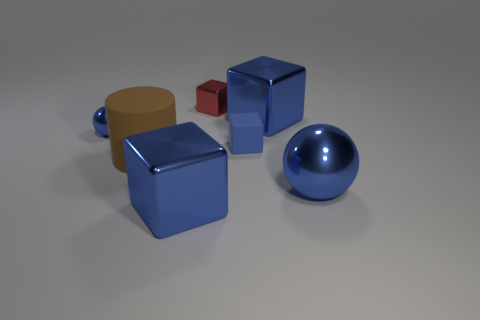There is a brown thing; is it the same size as the ball that is behind the big ball?
Give a very brief answer. No. There is a blue ball on the right side of the red cube; is its size the same as the brown object?
Ensure brevity in your answer.  Yes. How many other objects are the same material as the red thing?
Make the answer very short. 4. Are there an equal number of small blocks in front of the red thing and brown rubber cylinders in front of the big sphere?
Keep it short and to the point. No. What is the color of the big metallic thing that is in front of the sphere on the right side of the tiny block behind the tiny blue rubber block?
Provide a short and direct response. Blue. The large blue object left of the tiny rubber object has what shape?
Your answer should be compact. Cube. The other thing that is made of the same material as the large brown thing is what shape?
Offer a very short reply. Cube. Is there any other thing that has the same shape as the brown object?
Keep it short and to the point. No. There is a brown thing; how many tiny blue spheres are behind it?
Your answer should be compact. 1. Are there an equal number of red shiny cubes on the right side of the small blue rubber object and yellow metal cubes?
Provide a succinct answer. Yes. 